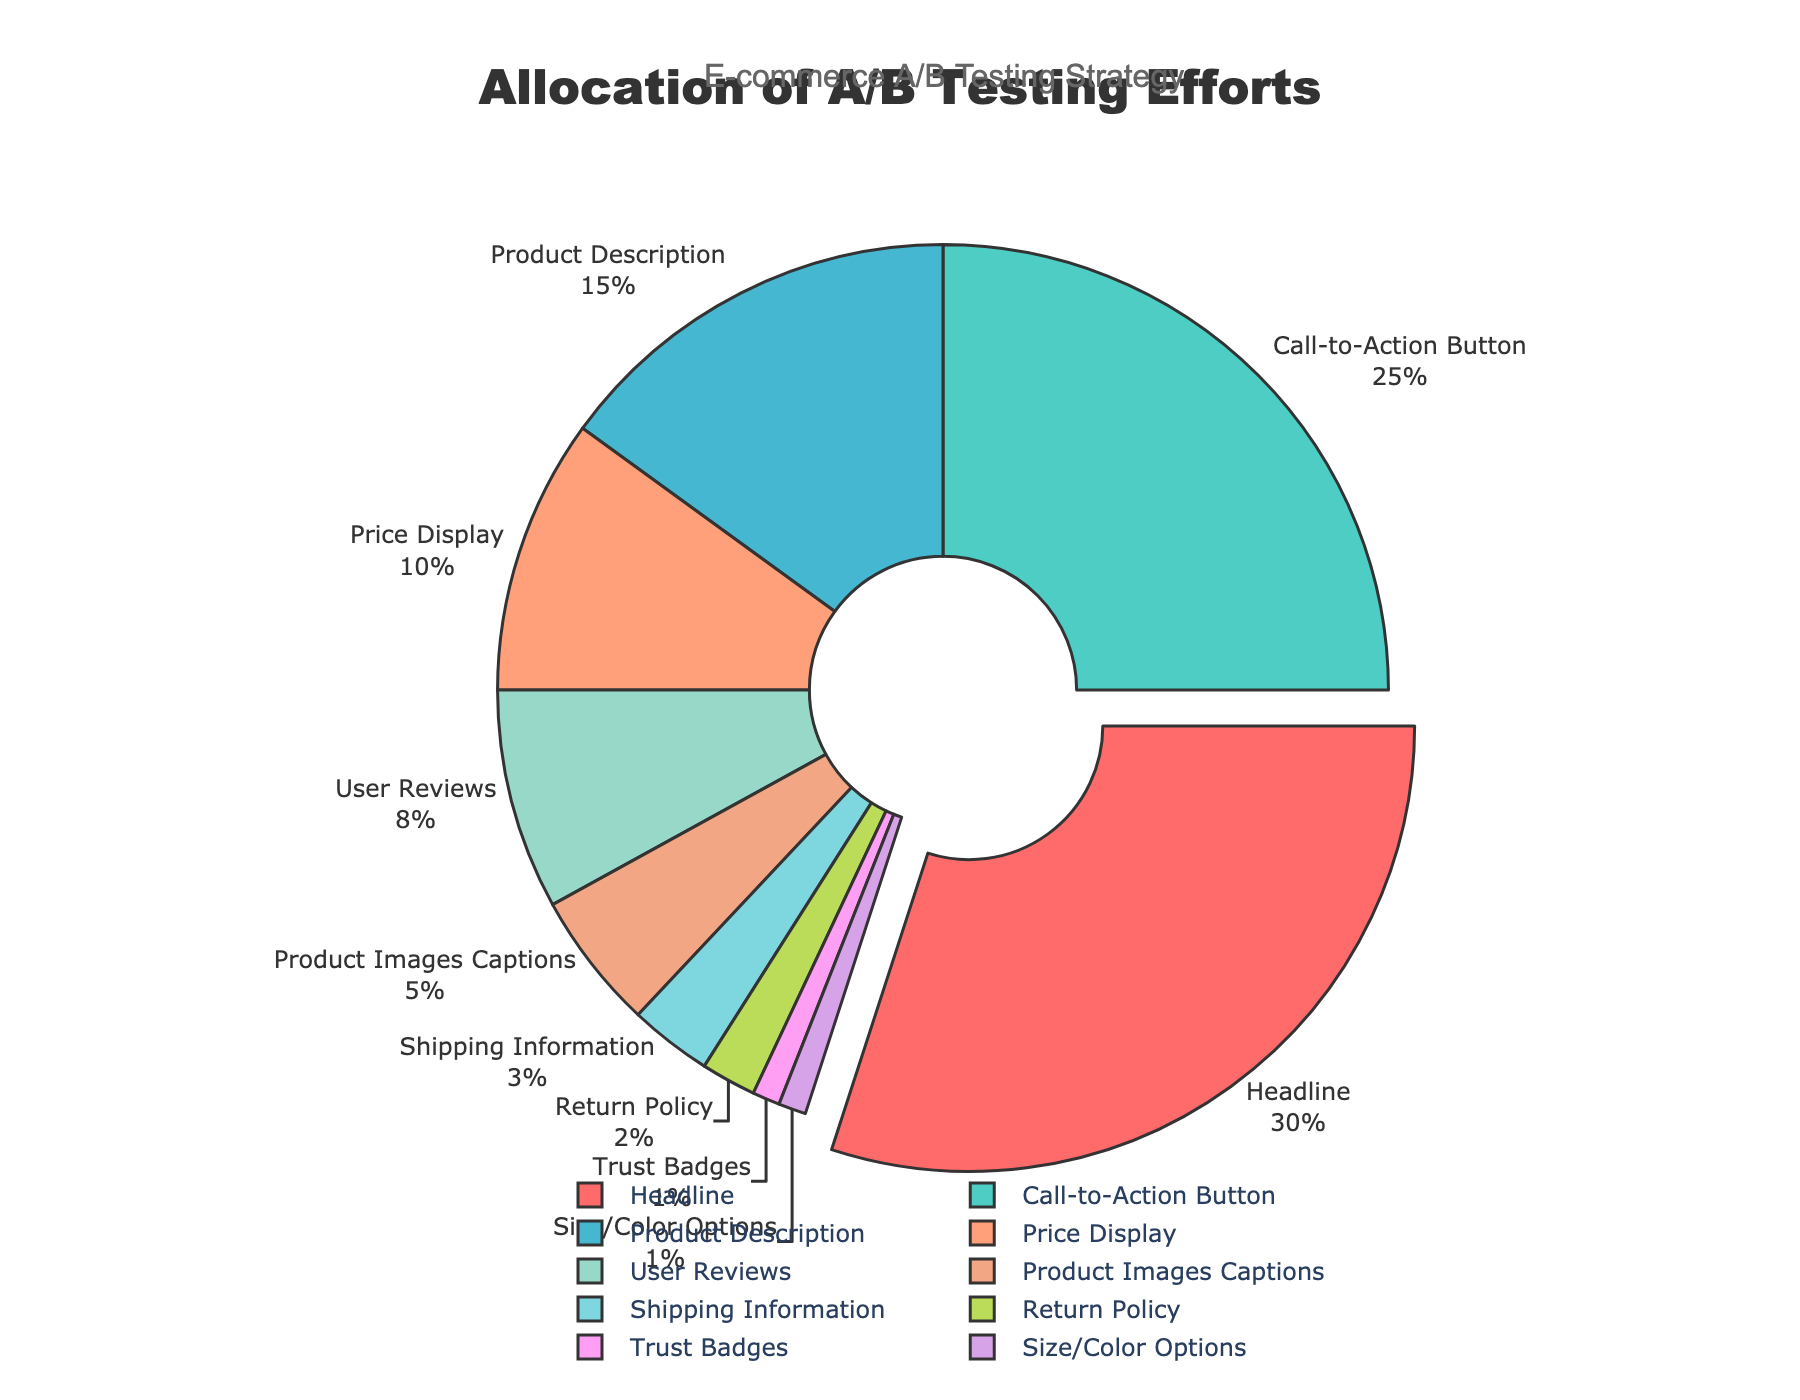Which element has the highest allocation of A/B testing efforts? By checking the labels and their associated percentages, we can see that the "Headline" has the highest allocation at 30%.
Answer: Headline Which two elements combined account for more than half of the A/B testing efforts? Combine the two highest percentages: Headline (30%) and Call-to-Action Button (25%). Together, they total to 55%, which is more than half.
Answer: Headline and Call-to-Action Button How much more effort is allocated to Product Description compared to User Reviews? Subtract the User Reviews percentage from the Product Description percentage (15% - 8% = 7%).
Answer: 7% What is the average percentage allocated to the elements with less than a 10% share? Sum the percentages of elements with less than 10%: Price Display (10%), User Reviews (8%), Product Images Captions (5%), Shipping Information (3%), Return Policy (2%), Trust Badges (1%), and Size/Color Options (1%), then average them: (10+8+5+3+2+1+1) / 7 ≈ 4.29.
Answer: Approximately 4.29% Which elements have an allocation difference of exactly 10 percentage points? Compare the differences between the percentages of each element. The elements "Price Display" (10%) and "Product Description" (15%) have a difference of 5 percentage points (15% - 10% = 5%). Hence, there is no pair with exactly a 10 percentage point difference.
Answer: None Which colored segment represents the Shipping Information element? Identify the color associated with the Shipping Information label (3%). It's visualized with a specific unique color on the pie chart.
Answer: Teal Are there more elements with an allocation of less than 10% or more than 10%? Count the elements under 10%: User Reviews, Product Images Captions, Shipping Information, Return Policy, Trust Badges, and Size/Color Options (6 elements). Then count the elements over 10%: Headline, Call-to-Action Button, Product Description, and Price Display (4 elements).
Answer: Less than 10% What percentage of A/B testing efforts is allocated to the bottom 50% of elements? To find the bottom 50% elements, combine the percentages of elements starting from the smallest: Trust Badges (1%), Size/Color Options (1%), Return Policy (2%), Shipping Information (3%), Product Images Captions (5%), and User Reviews (8%). These six elements add up to (1+1+2+3+5+8) = 20%.
Answer: 20% What proportion of the total effort is allocated to the Call-to-Action Button element compared to the Product Description? Divide the percentage of the Call-to-Action Button by the percentage of the Product Description (25% / 15% ≈ 1.67). This means the Call-to-Action Button is allocated about 1.67 times more effort.
Answer: 1.67 times Which element has the smallest allocation, and how does it compare to the Shipping Information allocation? The element with the smallest allocation is the Trust Badges (1%). Compare it to Shipping Information (3%): (3% - 1% = 2%).
Answer: Trust Badges, 2% less 